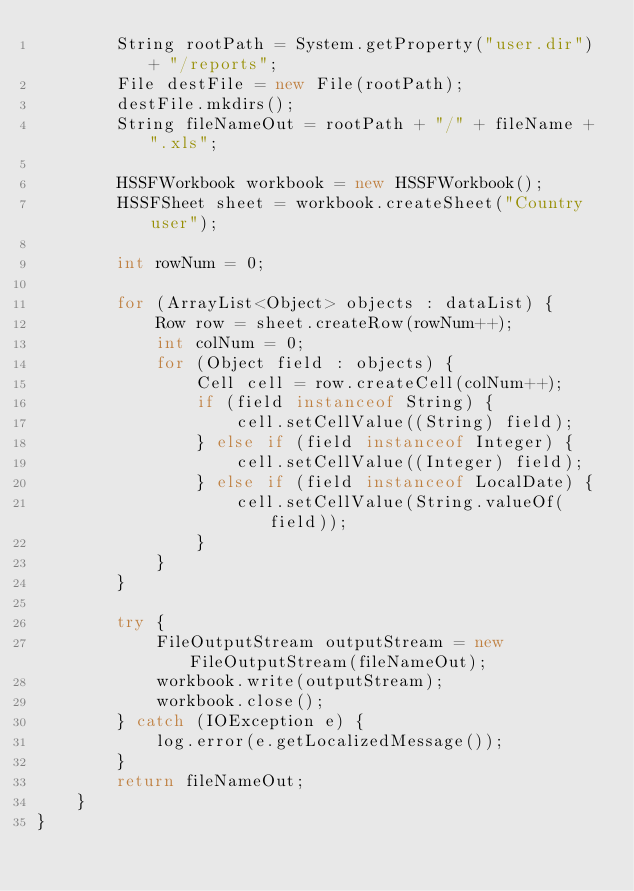Convert code to text. <code><loc_0><loc_0><loc_500><loc_500><_Java_>        String rootPath = System.getProperty("user.dir") + "/reports";
        File destFile = new File(rootPath);
        destFile.mkdirs();
        String fileNameOut = rootPath + "/" + fileName + ".xls";

        HSSFWorkbook workbook = new HSSFWorkbook();
        HSSFSheet sheet = workbook.createSheet("Country user");

        int rowNum = 0;

        for (ArrayList<Object> objects : dataList) {
            Row row = sheet.createRow(rowNum++);
            int colNum = 0;
            for (Object field : objects) {
                Cell cell = row.createCell(colNum++);
                if (field instanceof String) {
                    cell.setCellValue((String) field);
                } else if (field instanceof Integer) {
                    cell.setCellValue((Integer) field);
                } else if (field instanceof LocalDate) {
                    cell.setCellValue(String.valueOf(field));
                }
            }
        }

        try {
            FileOutputStream outputStream = new FileOutputStream(fileNameOut);
            workbook.write(outputStream);
            workbook.close();
        } catch (IOException e) {
            log.error(e.getLocalizedMessage());
        }
        return fileNameOut;
    }
}</code> 